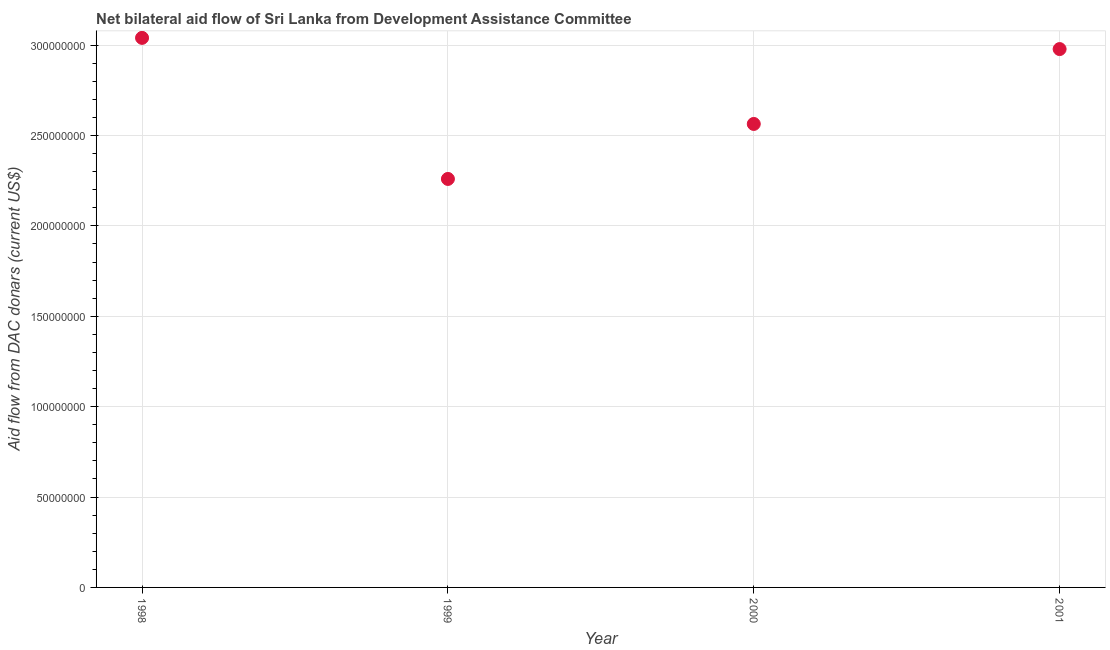What is the net bilateral aid flows from dac donors in 1999?
Your answer should be compact. 2.26e+08. Across all years, what is the maximum net bilateral aid flows from dac donors?
Your answer should be compact. 3.04e+08. Across all years, what is the minimum net bilateral aid flows from dac donors?
Offer a very short reply. 2.26e+08. What is the sum of the net bilateral aid flows from dac donors?
Your answer should be very brief. 1.08e+09. What is the difference between the net bilateral aid flows from dac donors in 1998 and 2001?
Make the answer very short. 6.19e+06. What is the average net bilateral aid flows from dac donors per year?
Provide a succinct answer. 2.71e+08. What is the median net bilateral aid flows from dac donors?
Ensure brevity in your answer.  2.77e+08. What is the ratio of the net bilateral aid flows from dac donors in 1998 to that in 2001?
Your response must be concise. 1.02. Is the net bilateral aid flows from dac donors in 1999 less than that in 2001?
Give a very brief answer. Yes. Is the difference between the net bilateral aid flows from dac donors in 1998 and 1999 greater than the difference between any two years?
Your response must be concise. Yes. What is the difference between the highest and the second highest net bilateral aid flows from dac donors?
Give a very brief answer. 6.19e+06. Is the sum of the net bilateral aid flows from dac donors in 2000 and 2001 greater than the maximum net bilateral aid flows from dac donors across all years?
Your answer should be compact. Yes. What is the difference between the highest and the lowest net bilateral aid flows from dac donors?
Your answer should be very brief. 7.80e+07. In how many years, is the net bilateral aid flows from dac donors greater than the average net bilateral aid flows from dac donors taken over all years?
Your answer should be compact. 2. How many years are there in the graph?
Offer a terse response. 4. Are the values on the major ticks of Y-axis written in scientific E-notation?
Provide a short and direct response. No. Does the graph contain any zero values?
Your response must be concise. No. Does the graph contain grids?
Ensure brevity in your answer.  Yes. What is the title of the graph?
Make the answer very short. Net bilateral aid flow of Sri Lanka from Development Assistance Committee. What is the label or title of the Y-axis?
Offer a terse response. Aid flow from DAC donars (current US$). What is the Aid flow from DAC donars (current US$) in 1998?
Give a very brief answer. 3.04e+08. What is the Aid flow from DAC donars (current US$) in 1999?
Ensure brevity in your answer.  2.26e+08. What is the Aid flow from DAC donars (current US$) in 2000?
Your answer should be compact. 2.56e+08. What is the Aid flow from DAC donars (current US$) in 2001?
Offer a terse response. 2.98e+08. What is the difference between the Aid flow from DAC donars (current US$) in 1998 and 1999?
Provide a short and direct response. 7.80e+07. What is the difference between the Aid flow from DAC donars (current US$) in 1998 and 2000?
Offer a terse response. 4.76e+07. What is the difference between the Aid flow from DAC donars (current US$) in 1998 and 2001?
Your response must be concise. 6.19e+06. What is the difference between the Aid flow from DAC donars (current US$) in 1999 and 2000?
Offer a terse response. -3.04e+07. What is the difference between the Aid flow from DAC donars (current US$) in 1999 and 2001?
Keep it short and to the point. -7.18e+07. What is the difference between the Aid flow from DAC donars (current US$) in 2000 and 2001?
Provide a short and direct response. -4.14e+07. What is the ratio of the Aid flow from DAC donars (current US$) in 1998 to that in 1999?
Offer a terse response. 1.34. What is the ratio of the Aid flow from DAC donars (current US$) in 1998 to that in 2000?
Your response must be concise. 1.19. What is the ratio of the Aid flow from DAC donars (current US$) in 1998 to that in 2001?
Keep it short and to the point. 1.02. What is the ratio of the Aid flow from DAC donars (current US$) in 1999 to that in 2000?
Your answer should be very brief. 0.88. What is the ratio of the Aid flow from DAC donars (current US$) in 1999 to that in 2001?
Offer a terse response. 0.76. What is the ratio of the Aid flow from DAC donars (current US$) in 2000 to that in 2001?
Ensure brevity in your answer.  0.86. 